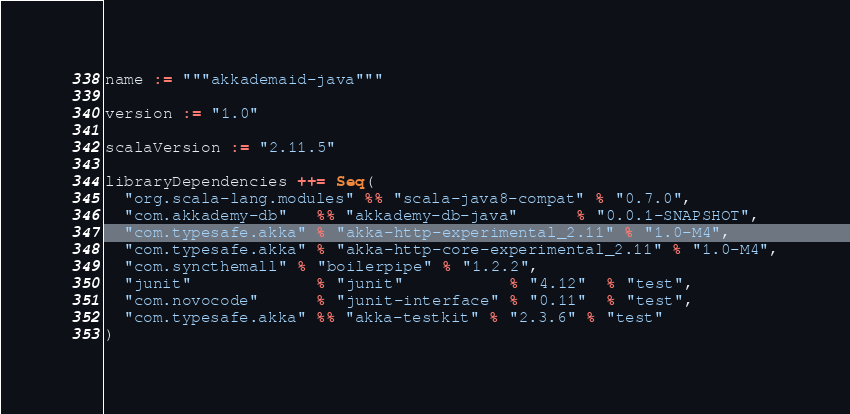Convert code to text. <code><loc_0><loc_0><loc_500><loc_500><_Scala_>name := """akkademaid-java"""

version := "1.0"

scalaVersion := "2.11.5"

libraryDependencies ++= Seq(
  "org.scala-lang.modules" %% "scala-java8-compat" % "0.7.0",
  "com.akkademy-db"   %% "akkademy-db-java"      % "0.0.1-SNAPSHOT",
  "com.typesafe.akka" % "akka-http-experimental_2.11" % "1.0-M4",
  "com.typesafe.akka" % "akka-http-core-experimental_2.11" % "1.0-M4",
  "com.syncthemall" % "boilerpipe" % "1.2.2",
  "junit"             % "junit"           % "4.12"  % "test",
  "com.novocode"      % "junit-interface" % "0.11"  % "test",
  "com.typesafe.akka" %% "akka-testkit" % "2.3.6" % "test"
)
</code> 